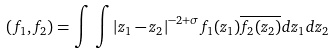Convert formula to latex. <formula><loc_0><loc_0><loc_500><loc_500>\left ( { f _ { 1 } , f _ { 2 } } \right ) = \int \, \int { \left | { z _ { 1 } - z _ { 2 } } \right | } ^ { - 2 + \sigma } f _ { 1 } ( z _ { 1 } ) \overline { f _ { 2 } ( z _ { 2 } ) } d z _ { 1 } d z _ { 2 }</formula> 